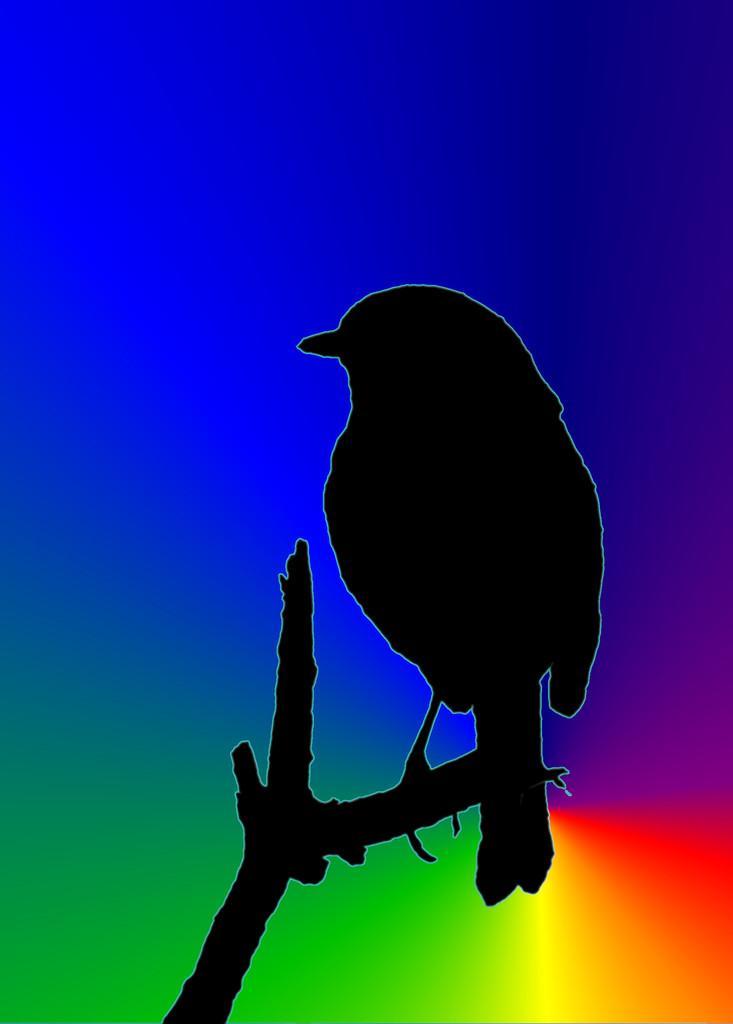Can you describe this image briefly? It is the graphical image in which there is a bird sitting on the tree stem. In the background there are different colors. 